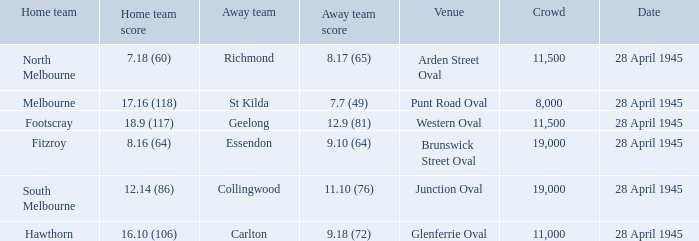What home team has an Away team of richmond? North Melbourne. Parse the table in full. {'header': ['Home team', 'Home team score', 'Away team', 'Away team score', 'Venue', 'Crowd', 'Date'], 'rows': [['North Melbourne', '7.18 (60)', 'Richmond', '8.17 (65)', 'Arden Street Oval', '11,500', '28 April 1945'], ['Melbourne', '17.16 (118)', 'St Kilda', '7.7 (49)', 'Punt Road Oval', '8,000', '28 April 1945'], ['Footscray', '18.9 (117)', 'Geelong', '12.9 (81)', 'Western Oval', '11,500', '28 April 1945'], ['Fitzroy', '8.16 (64)', 'Essendon', '9.10 (64)', 'Brunswick Street Oval', '19,000', '28 April 1945'], ['South Melbourne', '12.14 (86)', 'Collingwood', '11.10 (76)', 'Junction Oval', '19,000', '28 April 1945'], ['Hawthorn', '16.10 (106)', 'Carlton', '9.18 (72)', 'Glenferrie Oval', '11,000', '28 April 1945']]} 